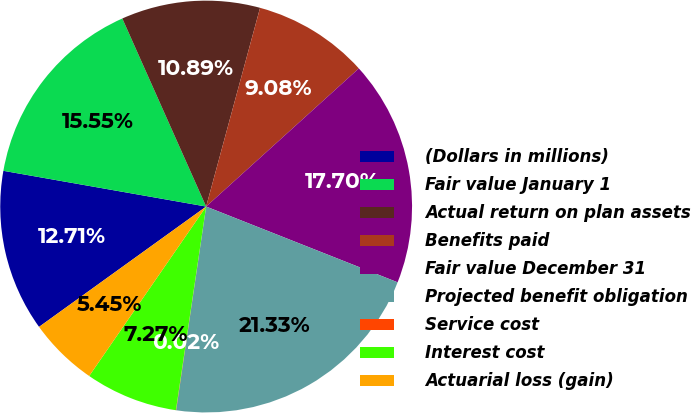Convert chart. <chart><loc_0><loc_0><loc_500><loc_500><pie_chart><fcel>(Dollars in millions)<fcel>Fair value January 1<fcel>Actual return on plan assets<fcel>Benefits paid<fcel>Fair value December 31<fcel>Projected benefit obligation<fcel>Service cost<fcel>Interest cost<fcel>Actuarial loss (gain)<nl><fcel>12.71%<fcel>15.55%<fcel>10.89%<fcel>9.08%<fcel>17.7%<fcel>21.33%<fcel>0.02%<fcel>7.27%<fcel>5.45%<nl></chart> 